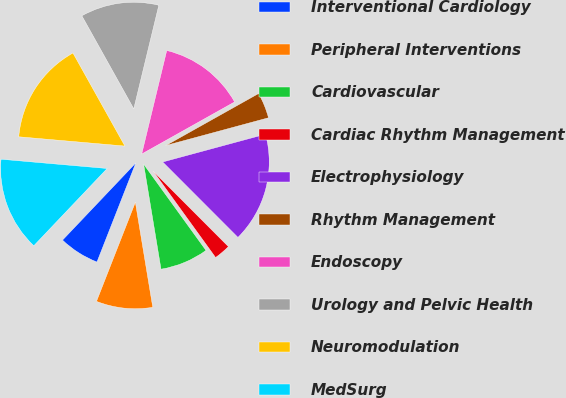<chart> <loc_0><loc_0><loc_500><loc_500><pie_chart><fcel>Interventional Cardiology<fcel>Peripheral Interventions<fcel>Cardiovascular<fcel>Cardiac Rhythm Management<fcel>Electrophysiology<fcel>Rhythm Management<fcel>Endoscopy<fcel>Urology and Pelvic Health<fcel>Neuromodulation<fcel>MedSurg<nl><fcel>6.14%<fcel>8.56%<fcel>7.35%<fcel>2.52%<fcel>16.72%<fcel>3.93%<fcel>13.09%<fcel>11.88%<fcel>15.51%<fcel>14.3%<nl></chart> 